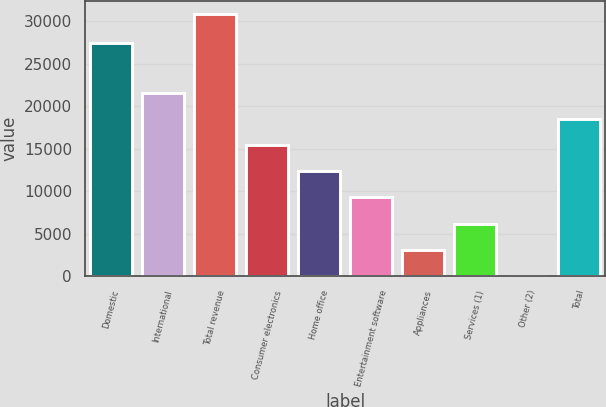Convert chart. <chart><loc_0><loc_0><loc_500><loc_500><bar_chart><fcel>Domestic<fcel>International<fcel>Total revenue<fcel>Consumer electronics<fcel>Home office<fcel>Entertainment software<fcel>Appliances<fcel>Services (1)<fcel>Other (2)<fcel>Total<nl><fcel>27380<fcel>21593.9<fcel>30848<fcel>15424.5<fcel>12339.8<fcel>9255.1<fcel>3085.7<fcel>6170.4<fcel>1<fcel>18509.2<nl></chart> 